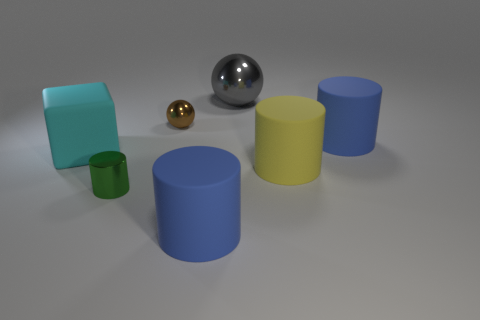Add 2 large blue rubber cylinders. How many objects exist? 9 Subtract all blocks. How many objects are left? 6 Subtract all tiny purple shiny cylinders. Subtract all green shiny things. How many objects are left? 6 Add 2 cylinders. How many cylinders are left? 6 Add 5 big yellow objects. How many big yellow objects exist? 6 Subtract 0 green balls. How many objects are left? 7 